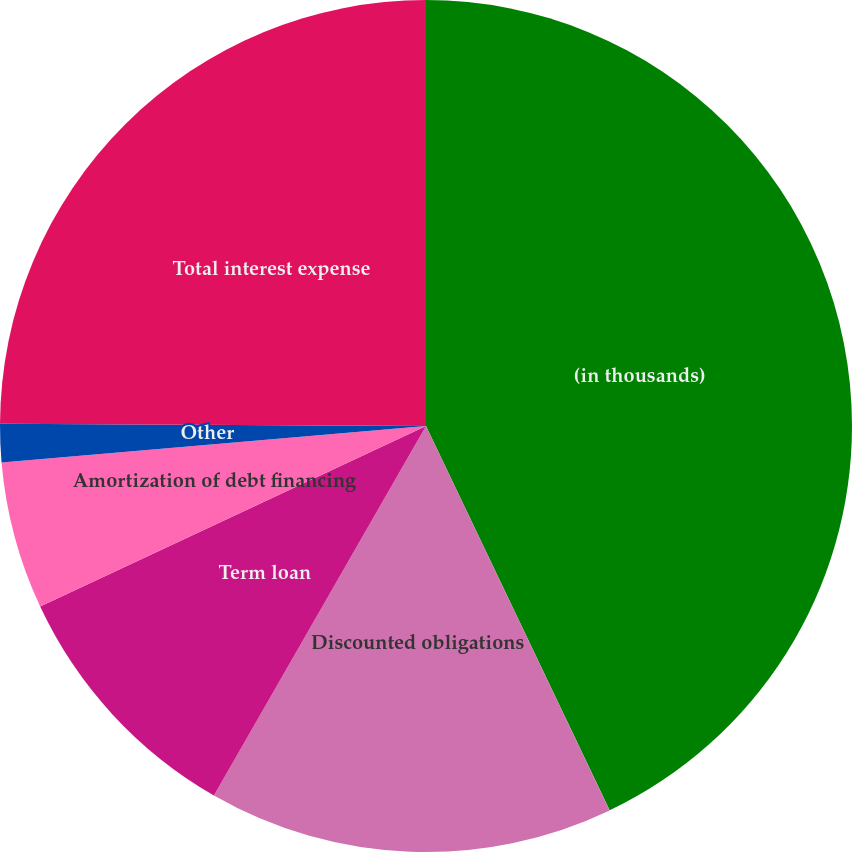Convert chart to OTSL. <chart><loc_0><loc_0><loc_500><loc_500><pie_chart><fcel>(in thousands)<fcel>Discounted obligations<fcel>Term loan<fcel>Amortization of debt financing<fcel>Other<fcel>Total interest expense<nl><fcel>42.91%<fcel>15.39%<fcel>9.74%<fcel>5.6%<fcel>1.45%<fcel>24.92%<nl></chart> 